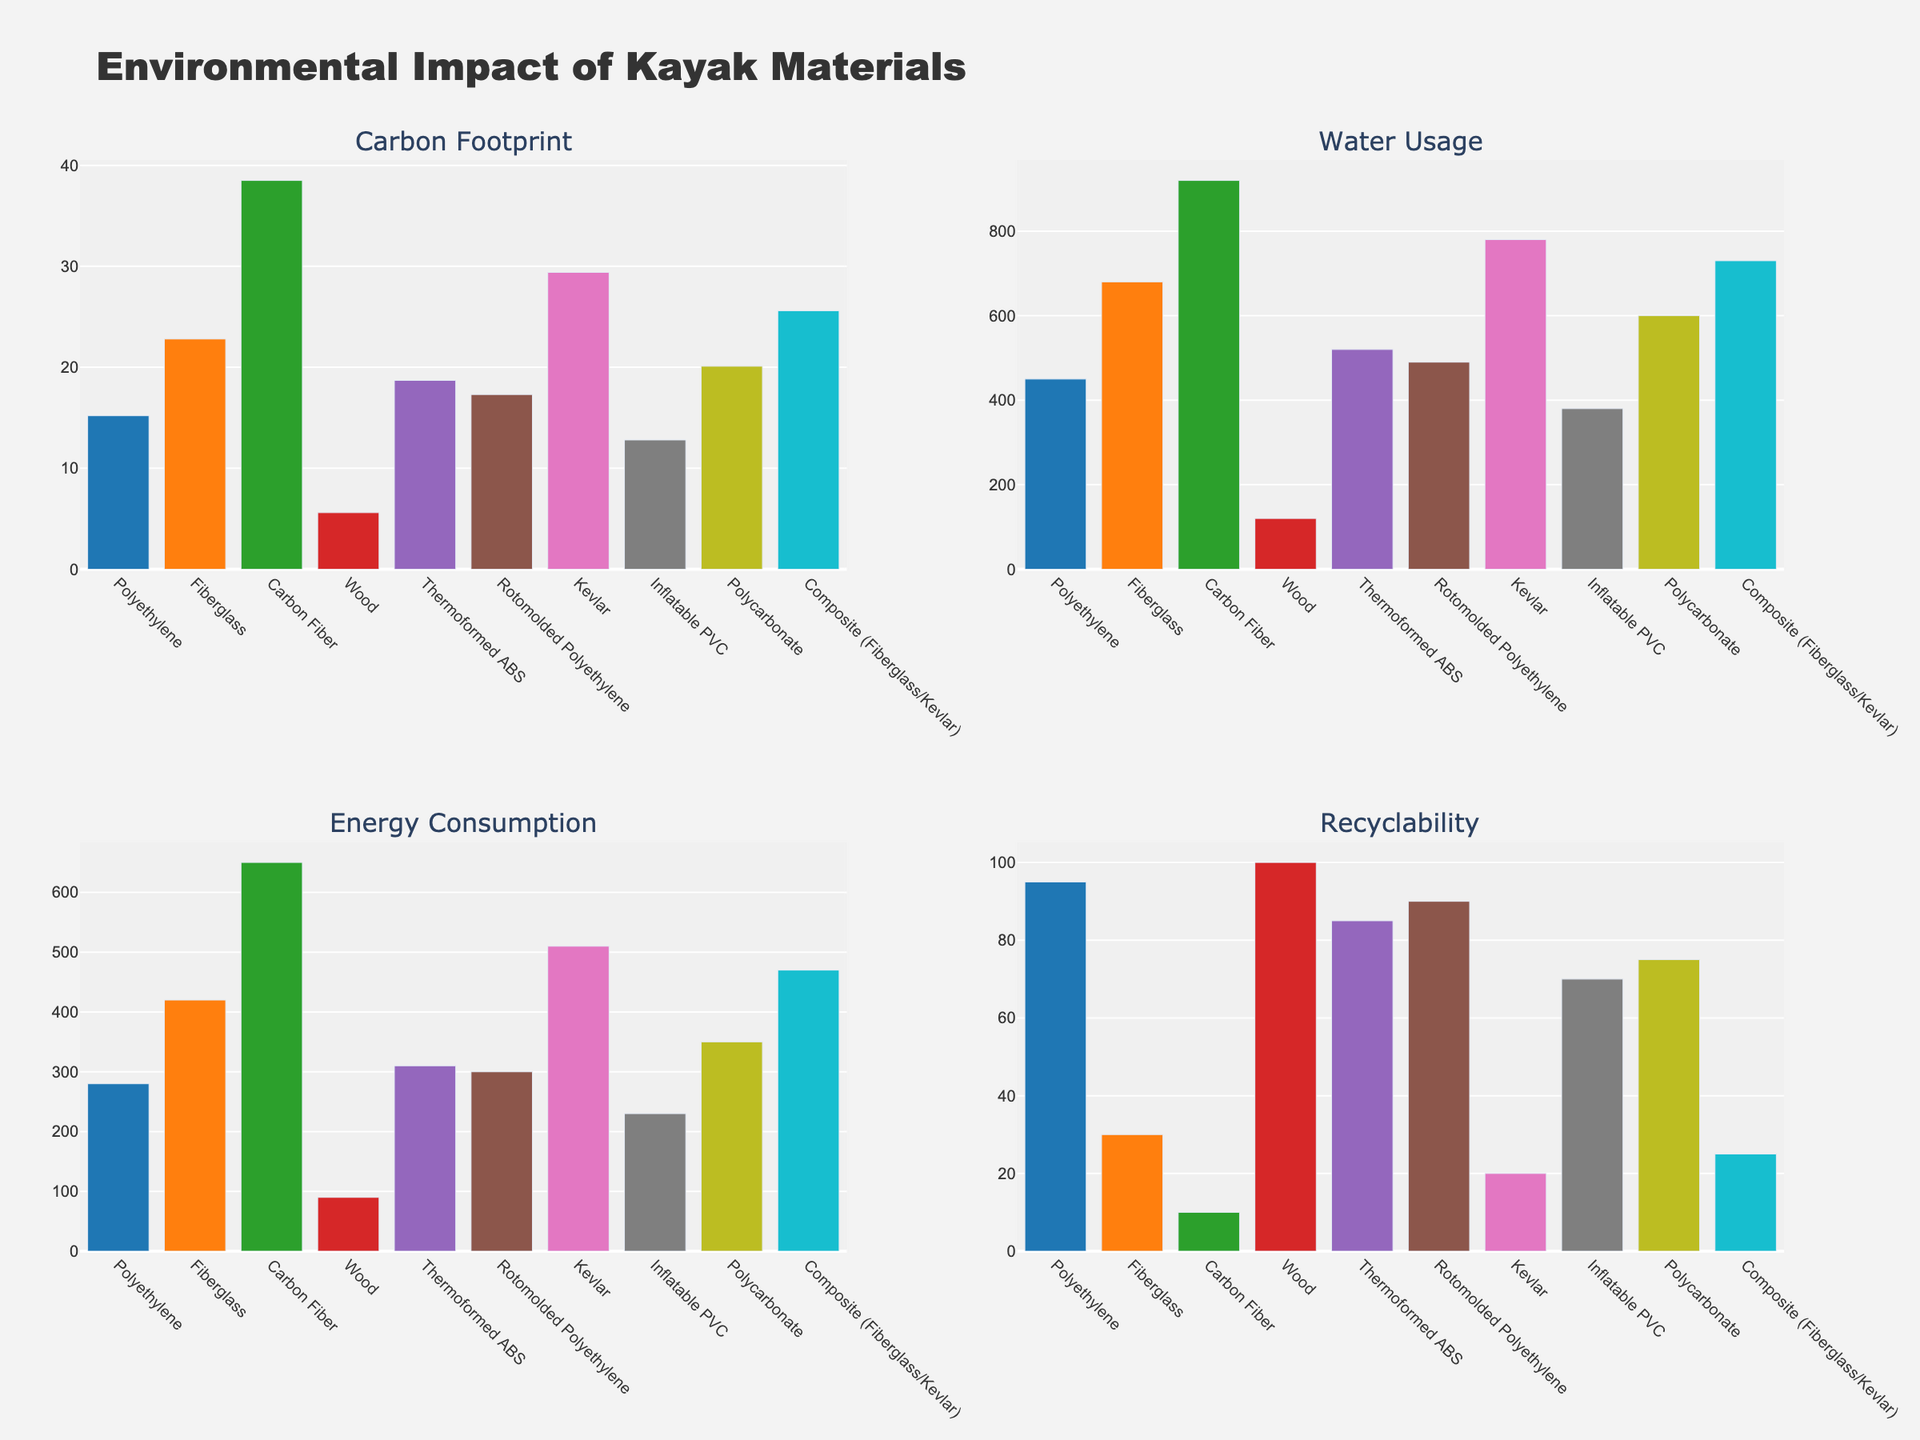What material has the highest carbon footprint? Observing the top left subplot, Carbon Fiber has the tallest bar, indicating the highest carbon footprint.
Answer: Carbon Fiber Which material uses the least amount of water? Checking the top right subplot, Wood has the shortest bar, indicating the lowest water usage.
Answer: Wood Compare the recyclability of materials with a carbon footprint below 20 kg CO2e. Which is the most recyclable? From the top left subplot, materials with a carbon footprint below 20 kg CO2e are: Polyethylene, Wood, Thermoformed ABS, Rotomolded Polyethylene, and Inflatable PVC. The bottom right subplot shows Wood has the highest recyclability among these.
Answer: Wood What is the difference in energy consumption between Fiberglass and Thermoformed ABS? From the bottom left subplot, subtract the energy consumption of Thermoformed ABS (310 MJ) from Fiberglass (420 MJ).
Answer: 110 MJ Which two materials show the closest levels of recyclability? Observing the bottom right subplot, Thermoformed ABS and Rotomolded Polyethylene have near-equal bars, indicating they have similar recyclability levels.
Answer: Thermoformed ABS and Rotomolded Polyethylene Which material has the largest difference between water usage and energy consumption? Calculate the difference in each material and look at the bar heights in the relevant subplots. Carbon Fiber has the largest difference calculated as 920 (Water Usage) - 650 (Energy Consumption) = 270.
Answer: Carbon Fiber Rank the materials by their carbon footprint from highest to lowest. Referring to the top left subplot, order the bars' heights from tallest to shortest: Carbon Fiber, Kevlar, Composite, Fiberglass, Polycarbonate, Thermoformed ABS, Rotomolded Polyethylene, Polyethylene, Inflatable PVC, Wood.
Answer: Carbon Fiber, Kevlar, Composite, Fiberglass, Polycarbonate, Thermoformed ABS, Rotomolded Polyethylene, Polyethylene, Inflatable PVC, Wood 